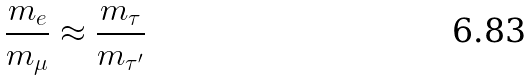Convert formula to latex. <formula><loc_0><loc_0><loc_500><loc_500>\frac { { m _ { e } } } { { m _ { \mu } } } \approx \frac { { m _ { \tau } } } { { m _ { \tau ^ { \prime } } } }</formula> 